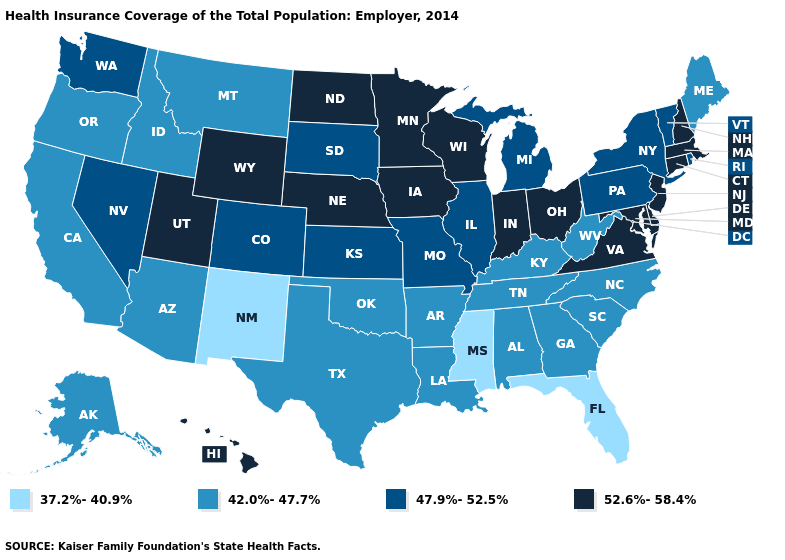What is the value of Michigan?
Write a very short answer. 47.9%-52.5%. What is the lowest value in the USA?
Give a very brief answer. 37.2%-40.9%. What is the value of Rhode Island?
Write a very short answer. 47.9%-52.5%. What is the value of Nebraska?
Keep it brief. 52.6%-58.4%. What is the value of Delaware?
Concise answer only. 52.6%-58.4%. Name the states that have a value in the range 42.0%-47.7%?
Write a very short answer. Alabama, Alaska, Arizona, Arkansas, California, Georgia, Idaho, Kentucky, Louisiana, Maine, Montana, North Carolina, Oklahoma, Oregon, South Carolina, Tennessee, Texas, West Virginia. What is the value of New York?
Give a very brief answer. 47.9%-52.5%. What is the value of Idaho?
Keep it brief. 42.0%-47.7%. Name the states that have a value in the range 52.6%-58.4%?
Be succinct. Connecticut, Delaware, Hawaii, Indiana, Iowa, Maryland, Massachusetts, Minnesota, Nebraska, New Hampshire, New Jersey, North Dakota, Ohio, Utah, Virginia, Wisconsin, Wyoming. Which states have the lowest value in the USA?
Be succinct. Florida, Mississippi, New Mexico. Among the states that border New Hampshire , does Maine have the lowest value?
Answer briefly. Yes. What is the highest value in the MidWest ?
Give a very brief answer. 52.6%-58.4%. Name the states that have a value in the range 42.0%-47.7%?
Be succinct. Alabama, Alaska, Arizona, Arkansas, California, Georgia, Idaho, Kentucky, Louisiana, Maine, Montana, North Carolina, Oklahoma, Oregon, South Carolina, Tennessee, Texas, West Virginia. What is the value of Illinois?
Concise answer only. 47.9%-52.5%. 